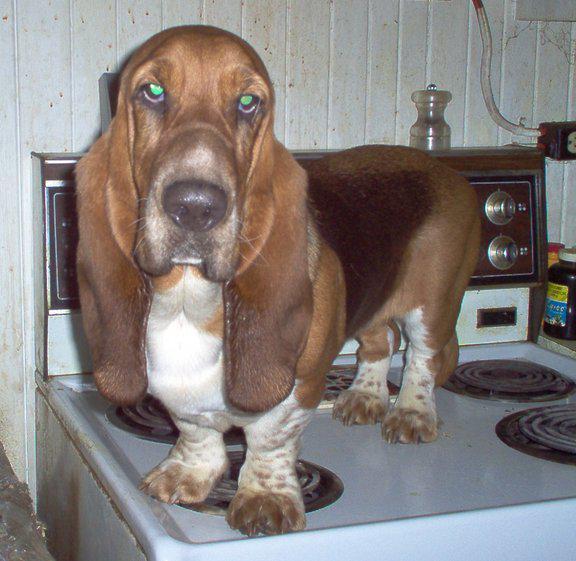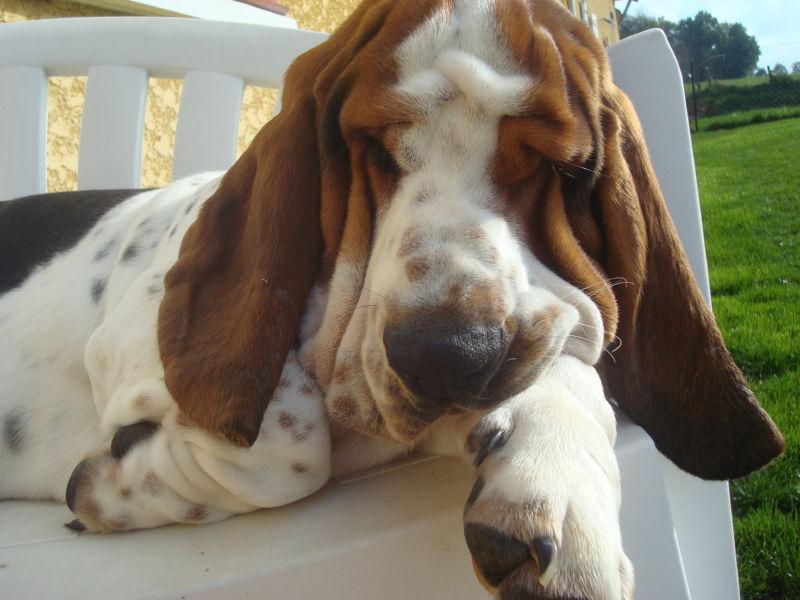The first image is the image on the left, the second image is the image on the right. Analyze the images presented: Is the assertion "The dog in the left image is laying down." valid? Answer yes or no. No. The first image is the image on the left, the second image is the image on the right. Assess this claim about the two images: "on the left picture the dog has their head laying down". Correct or not? Answer yes or no. No. 